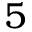<formula> <loc_0><loc_0><loc_500><loc_500>5</formula> 